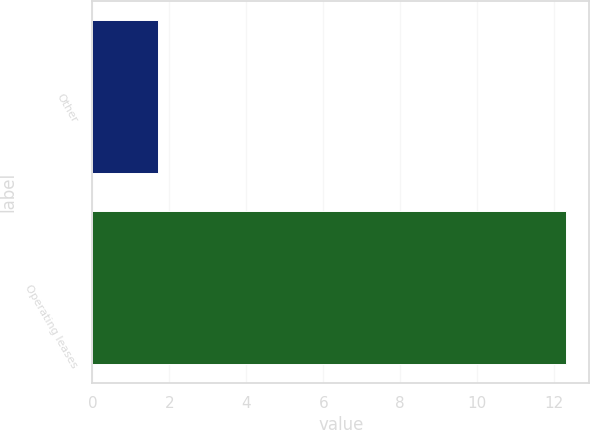Convert chart. <chart><loc_0><loc_0><loc_500><loc_500><bar_chart><fcel>Other<fcel>Operating leases<nl><fcel>1.7<fcel>12.3<nl></chart> 